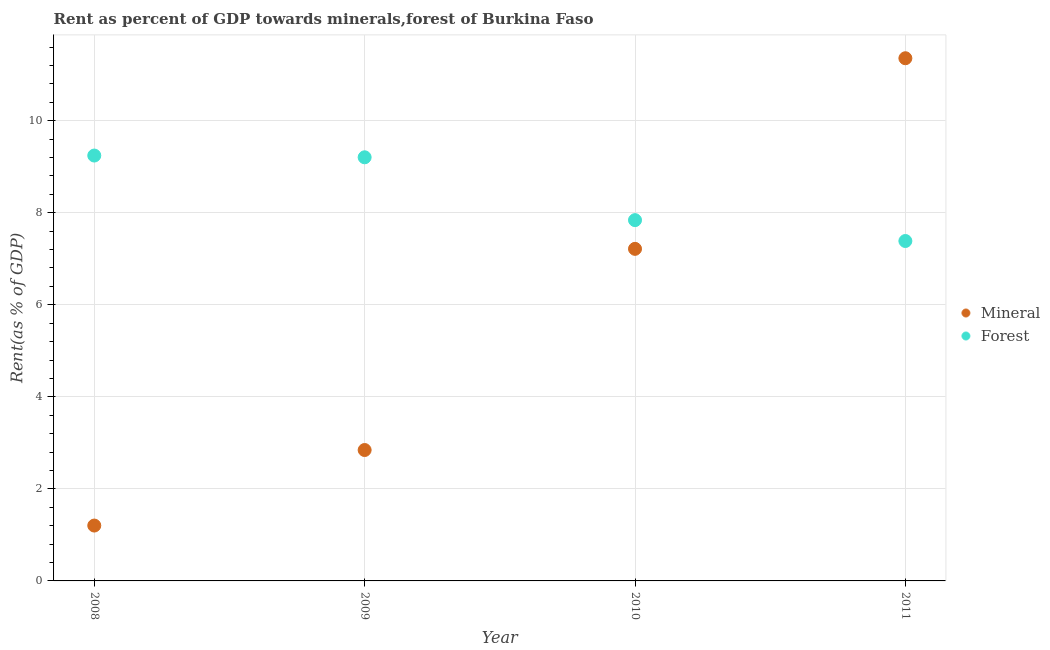How many different coloured dotlines are there?
Ensure brevity in your answer.  2. Is the number of dotlines equal to the number of legend labels?
Offer a very short reply. Yes. What is the forest rent in 2010?
Ensure brevity in your answer.  7.84. Across all years, what is the maximum forest rent?
Offer a terse response. 9.24. Across all years, what is the minimum mineral rent?
Give a very brief answer. 1.2. In which year was the mineral rent maximum?
Provide a short and direct response. 2011. What is the total mineral rent in the graph?
Make the answer very short. 22.62. What is the difference between the forest rent in 2009 and that in 2010?
Your answer should be compact. 1.37. What is the difference between the forest rent in 2009 and the mineral rent in 2008?
Your answer should be compact. 8. What is the average mineral rent per year?
Ensure brevity in your answer.  5.65. In the year 2008, what is the difference between the mineral rent and forest rent?
Ensure brevity in your answer.  -8.04. What is the ratio of the mineral rent in 2008 to that in 2010?
Provide a short and direct response. 0.17. Is the mineral rent in 2008 less than that in 2009?
Provide a short and direct response. Yes. What is the difference between the highest and the second highest mineral rent?
Offer a very short reply. 4.14. What is the difference between the highest and the lowest mineral rent?
Provide a short and direct response. 10.15. In how many years, is the forest rent greater than the average forest rent taken over all years?
Keep it short and to the point. 2. Is the sum of the mineral rent in 2010 and 2011 greater than the maximum forest rent across all years?
Offer a terse response. Yes. Does the forest rent monotonically increase over the years?
Keep it short and to the point. No. Is the forest rent strictly less than the mineral rent over the years?
Your response must be concise. No. How many dotlines are there?
Give a very brief answer. 2. Are the values on the major ticks of Y-axis written in scientific E-notation?
Give a very brief answer. No. Does the graph contain grids?
Provide a short and direct response. Yes. What is the title of the graph?
Your answer should be very brief. Rent as percent of GDP towards minerals,forest of Burkina Faso. Does "Under-5(male)" appear as one of the legend labels in the graph?
Provide a short and direct response. No. What is the label or title of the X-axis?
Provide a succinct answer. Year. What is the label or title of the Y-axis?
Provide a succinct answer. Rent(as % of GDP). What is the Rent(as % of GDP) of Mineral in 2008?
Offer a terse response. 1.2. What is the Rent(as % of GDP) in Forest in 2008?
Your answer should be compact. 9.24. What is the Rent(as % of GDP) in Mineral in 2009?
Provide a succinct answer. 2.84. What is the Rent(as % of GDP) in Forest in 2009?
Give a very brief answer. 9.2. What is the Rent(as % of GDP) in Mineral in 2010?
Your response must be concise. 7.22. What is the Rent(as % of GDP) in Forest in 2010?
Your response must be concise. 7.84. What is the Rent(as % of GDP) in Mineral in 2011?
Ensure brevity in your answer.  11.36. What is the Rent(as % of GDP) in Forest in 2011?
Your answer should be very brief. 7.39. Across all years, what is the maximum Rent(as % of GDP) in Mineral?
Offer a very short reply. 11.36. Across all years, what is the maximum Rent(as % of GDP) of Forest?
Make the answer very short. 9.24. Across all years, what is the minimum Rent(as % of GDP) in Mineral?
Offer a very short reply. 1.2. Across all years, what is the minimum Rent(as % of GDP) of Forest?
Provide a short and direct response. 7.39. What is the total Rent(as % of GDP) of Mineral in the graph?
Your response must be concise. 22.62. What is the total Rent(as % of GDP) of Forest in the graph?
Ensure brevity in your answer.  33.67. What is the difference between the Rent(as % of GDP) in Mineral in 2008 and that in 2009?
Your answer should be compact. -1.64. What is the difference between the Rent(as % of GDP) of Forest in 2008 and that in 2009?
Offer a terse response. 0.04. What is the difference between the Rent(as % of GDP) of Mineral in 2008 and that in 2010?
Keep it short and to the point. -6.01. What is the difference between the Rent(as % of GDP) of Forest in 2008 and that in 2010?
Make the answer very short. 1.4. What is the difference between the Rent(as % of GDP) of Mineral in 2008 and that in 2011?
Give a very brief answer. -10.15. What is the difference between the Rent(as % of GDP) in Forest in 2008 and that in 2011?
Your answer should be compact. 1.86. What is the difference between the Rent(as % of GDP) in Mineral in 2009 and that in 2010?
Offer a terse response. -4.37. What is the difference between the Rent(as % of GDP) of Forest in 2009 and that in 2010?
Provide a succinct answer. 1.37. What is the difference between the Rent(as % of GDP) of Mineral in 2009 and that in 2011?
Provide a short and direct response. -8.51. What is the difference between the Rent(as % of GDP) in Forest in 2009 and that in 2011?
Your response must be concise. 1.82. What is the difference between the Rent(as % of GDP) of Mineral in 2010 and that in 2011?
Ensure brevity in your answer.  -4.14. What is the difference between the Rent(as % of GDP) of Forest in 2010 and that in 2011?
Offer a very short reply. 0.45. What is the difference between the Rent(as % of GDP) in Mineral in 2008 and the Rent(as % of GDP) in Forest in 2009?
Ensure brevity in your answer.  -8. What is the difference between the Rent(as % of GDP) of Mineral in 2008 and the Rent(as % of GDP) of Forest in 2010?
Provide a succinct answer. -6.64. What is the difference between the Rent(as % of GDP) of Mineral in 2008 and the Rent(as % of GDP) of Forest in 2011?
Offer a very short reply. -6.18. What is the difference between the Rent(as % of GDP) of Mineral in 2009 and the Rent(as % of GDP) of Forest in 2010?
Your answer should be compact. -4.99. What is the difference between the Rent(as % of GDP) of Mineral in 2009 and the Rent(as % of GDP) of Forest in 2011?
Offer a very short reply. -4.54. What is the difference between the Rent(as % of GDP) of Mineral in 2010 and the Rent(as % of GDP) of Forest in 2011?
Ensure brevity in your answer.  -0.17. What is the average Rent(as % of GDP) of Mineral per year?
Offer a very short reply. 5.65. What is the average Rent(as % of GDP) of Forest per year?
Provide a succinct answer. 8.42. In the year 2008, what is the difference between the Rent(as % of GDP) of Mineral and Rent(as % of GDP) of Forest?
Your response must be concise. -8.04. In the year 2009, what is the difference between the Rent(as % of GDP) of Mineral and Rent(as % of GDP) of Forest?
Provide a succinct answer. -6.36. In the year 2010, what is the difference between the Rent(as % of GDP) in Mineral and Rent(as % of GDP) in Forest?
Give a very brief answer. -0.62. In the year 2011, what is the difference between the Rent(as % of GDP) in Mineral and Rent(as % of GDP) in Forest?
Provide a short and direct response. 3.97. What is the ratio of the Rent(as % of GDP) of Mineral in 2008 to that in 2009?
Ensure brevity in your answer.  0.42. What is the ratio of the Rent(as % of GDP) of Forest in 2008 to that in 2010?
Keep it short and to the point. 1.18. What is the ratio of the Rent(as % of GDP) in Mineral in 2008 to that in 2011?
Ensure brevity in your answer.  0.11. What is the ratio of the Rent(as % of GDP) in Forest in 2008 to that in 2011?
Provide a succinct answer. 1.25. What is the ratio of the Rent(as % of GDP) in Mineral in 2009 to that in 2010?
Provide a succinct answer. 0.39. What is the ratio of the Rent(as % of GDP) in Forest in 2009 to that in 2010?
Give a very brief answer. 1.17. What is the ratio of the Rent(as % of GDP) of Mineral in 2009 to that in 2011?
Offer a terse response. 0.25. What is the ratio of the Rent(as % of GDP) of Forest in 2009 to that in 2011?
Provide a succinct answer. 1.25. What is the ratio of the Rent(as % of GDP) in Mineral in 2010 to that in 2011?
Ensure brevity in your answer.  0.64. What is the ratio of the Rent(as % of GDP) of Forest in 2010 to that in 2011?
Give a very brief answer. 1.06. What is the difference between the highest and the second highest Rent(as % of GDP) in Mineral?
Keep it short and to the point. 4.14. What is the difference between the highest and the second highest Rent(as % of GDP) in Forest?
Ensure brevity in your answer.  0.04. What is the difference between the highest and the lowest Rent(as % of GDP) in Mineral?
Your answer should be very brief. 10.15. What is the difference between the highest and the lowest Rent(as % of GDP) in Forest?
Give a very brief answer. 1.86. 